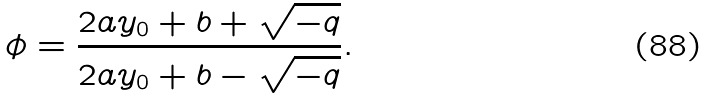Convert formula to latex. <formula><loc_0><loc_0><loc_500><loc_500>\phi = \frac { 2 a y _ { 0 } + b + \sqrt { - q } } { 2 a y _ { 0 } + b - \sqrt { - q } } .</formula> 